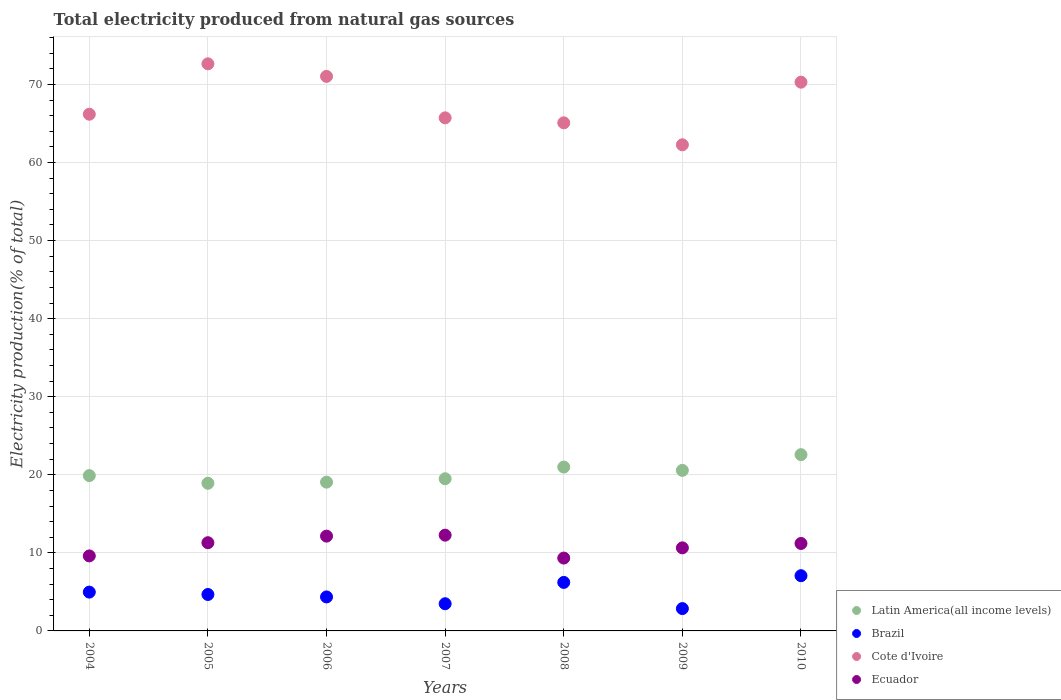Is the number of dotlines equal to the number of legend labels?
Provide a short and direct response. Yes. What is the total electricity produced in Latin America(all income levels) in 2008?
Your answer should be very brief. 20.99. Across all years, what is the maximum total electricity produced in Ecuador?
Offer a very short reply. 12.27. Across all years, what is the minimum total electricity produced in Ecuador?
Ensure brevity in your answer.  9.33. In which year was the total electricity produced in Brazil minimum?
Provide a succinct answer. 2009. What is the total total electricity produced in Ecuador in the graph?
Offer a very short reply. 76.49. What is the difference between the total electricity produced in Cote d'Ivoire in 2004 and that in 2010?
Keep it short and to the point. -4.1. What is the difference between the total electricity produced in Brazil in 2007 and the total electricity produced in Ecuador in 2009?
Ensure brevity in your answer.  -7.16. What is the average total electricity produced in Brazil per year?
Provide a succinct answer. 4.8. In the year 2010, what is the difference between the total electricity produced in Latin America(all income levels) and total electricity produced in Ecuador?
Your answer should be compact. 11.38. What is the ratio of the total electricity produced in Cote d'Ivoire in 2006 to that in 2008?
Keep it short and to the point. 1.09. Is the total electricity produced in Cote d'Ivoire in 2006 less than that in 2010?
Your response must be concise. No. Is the difference between the total electricity produced in Latin America(all income levels) in 2005 and 2006 greater than the difference between the total electricity produced in Ecuador in 2005 and 2006?
Your response must be concise. Yes. What is the difference between the highest and the second highest total electricity produced in Brazil?
Give a very brief answer. 0.86. What is the difference between the highest and the lowest total electricity produced in Cote d'Ivoire?
Make the answer very short. 10.37. In how many years, is the total electricity produced in Ecuador greater than the average total electricity produced in Ecuador taken over all years?
Offer a very short reply. 4. Is the sum of the total electricity produced in Cote d'Ivoire in 2004 and 2008 greater than the maximum total electricity produced in Latin America(all income levels) across all years?
Your answer should be compact. Yes. Is it the case that in every year, the sum of the total electricity produced in Cote d'Ivoire and total electricity produced in Ecuador  is greater than the total electricity produced in Latin America(all income levels)?
Offer a terse response. Yes. Is the total electricity produced in Cote d'Ivoire strictly less than the total electricity produced in Brazil over the years?
Provide a short and direct response. No. How many years are there in the graph?
Make the answer very short. 7. What is the difference between two consecutive major ticks on the Y-axis?
Provide a short and direct response. 10. Are the values on the major ticks of Y-axis written in scientific E-notation?
Provide a succinct answer. No. Does the graph contain grids?
Give a very brief answer. Yes. Where does the legend appear in the graph?
Your answer should be very brief. Bottom right. How many legend labels are there?
Provide a short and direct response. 4. How are the legend labels stacked?
Your answer should be very brief. Vertical. What is the title of the graph?
Keep it short and to the point. Total electricity produced from natural gas sources. Does "Philippines" appear as one of the legend labels in the graph?
Offer a very short reply. No. What is the label or title of the X-axis?
Make the answer very short. Years. What is the label or title of the Y-axis?
Your answer should be very brief. Electricity production(% of total). What is the Electricity production(% of total) in Latin America(all income levels) in 2004?
Your answer should be very brief. 19.9. What is the Electricity production(% of total) of Brazil in 2004?
Make the answer very short. 4.97. What is the Electricity production(% of total) in Cote d'Ivoire in 2004?
Your response must be concise. 66.19. What is the Electricity production(% of total) of Ecuador in 2004?
Keep it short and to the point. 9.61. What is the Electricity production(% of total) of Latin America(all income levels) in 2005?
Ensure brevity in your answer.  18.91. What is the Electricity production(% of total) in Brazil in 2005?
Your response must be concise. 4.67. What is the Electricity production(% of total) in Cote d'Ivoire in 2005?
Offer a terse response. 72.65. What is the Electricity production(% of total) of Ecuador in 2005?
Keep it short and to the point. 11.3. What is the Electricity production(% of total) of Latin America(all income levels) in 2006?
Make the answer very short. 19.06. What is the Electricity production(% of total) of Brazil in 2006?
Make the answer very short. 4.35. What is the Electricity production(% of total) of Cote d'Ivoire in 2006?
Your answer should be very brief. 71.03. What is the Electricity production(% of total) in Ecuador in 2006?
Offer a terse response. 12.14. What is the Electricity production(% of total) in Latin America(all income levels) in 2007?
Offer a very short reply. 19.49. What is the Electricity production(% of total) of Brazil in 2007?
Keep it short and to the point. 3.48. What is the Electricity production(% of total) of Cote d'Ivoire in 2007?
Provide a short and direct response. 65.73. What is the Electricity production(% of total) of Ecuador in 2007?
Offer a very short reply. 12.27. What is the Electricity production(% of total) of Latin America(all income levels) in 2008?
Your answer should be very brief. 20.99. What is the Electricity production(% of total) in Brazil in 2008?
Your answer should be compact. 6.21. What is the Electricity production(% of total) in Cote d'Ivoire in 2008?
Give a very brief answer. 65.09. What is the Electricity production(% of total) in Ecuador in 2008?
Offer a very short reply. 9.33. What is the Electricity production(% of total) of Latin America(all income levels) in 2009?
Your response must be concise. 20.57. What is the Electricity production(% of total) of Brazil in 2009?
Your answer should be compact. 2.86. What is the Electricity production(% of total) of Cote d'Ivoire in 2009?
Your answer should be compact. 62.27. What is the Electricity production(% of total) of Ecuador in 2009?
Keep it short and to the point. 10.64. What is the Electricity production(% of total) in Latin America(all income levels) in 2010?
Give a very brief answer. 22.58. What is the Electricity production(% of total) in Brazil in 2010?
Your answer should be compact. 7.07. What is the Electricity production(% of total) in Cote d'Ivoire in 2010?
Your answer should be very brief. 70.29. What is the Electricity production(% of total) of Ecuador in 2010?
Offer a terse response. 11.2. Across all years, what is the maximum Electricity production(% of total) in Latin America(all income levels)?
Your response must be concise. 22.58. Across all years, what is the maximum Electricity production(% of total) in Brazil?
Your response must be concise. 7.07. Across all years, what is the maximum Electricity production(% of total) of Cote d'Ivoire?
Offer a very short reply. 72.65. Across all years, what is the maximum Electricity production(% of total) of Ecuador?
Provide a short and direct response. 12.27. Across all years, what is the minimum Electricity production(% of total) of Latin America(all income levels)?
Ensure brevity in your answer.  18.91. Across all years, what is the minimum Electricity production(% of total) in Brazil?
Keep it short and to the point. 2.86. Across all years, what is the minimum Electricity production(% of total) in Cote d'Ivoire?
Provide a short and direct response. 62.27. Across all years, what is the minimum Electricity production(% of total) of Ecuador?
Offer a terse response. 9.33. What is the total Electricity production(% of total) of Latin America(all income levels) in the graph?
Your response must be concise. 141.5. What is the total Electricity production(% of total) in Brazil in the graph?
Offer a very short reply. 33.62. What is the total Electricity production(% of total) of Cote d'Ivoire in the graph?
Your answer should be very brief. 473.25. What is the total Electricity production(% of total) of Ecuador in the graph?
Keep it short and to the point. 76.49. What is the difference between the Electricity production(% of total) of Latin America(all income levels) in 2004 and that in 2005?
Make the answer very short. 0.98. What is the difference between the Electricity production(% of total) in Brazil in 2004 and that in 2005?
Your response must be concise. 0.3. What is the difference between the Electricity production(% of total) in Cote d'Ivoire in 2004 and that in 2005?
Your answer should be compact. -6.46. What is the difference between the Electricity production(% of total) of Ecuador in 2004 and that in 2005?
Offer a very short reply. -1.69. What is the difference between the Electricity production(% of total) of Latin America(all income levels) in 2004 and that in 2006?
Your answer should be compact. 0.84. What is the difference between the Electricity production(% of total) of Brazil in 2004 and that in 2006?
Offer a terse response. 0.62. What is the difference between the Electricity production(% of total) in Cote d'Ivoire in 2004 and that in 2006?
Your response must be concise. -4.85. What is the difference between the Electricity production(% of total) of Ecuador in 2004 and that in 2006?
Give a very brief answer. -2.53. What is the difference between the Electricity production(% of total) of Latin America(all income levels) in 2004 and that in 2007?
Provide a short and direct response. 0.4. What is the difference between the Electricity production(% of total) of Brazil in 2004 and that in 2007?
Your response must be concise. 1.49. What is the difference between the Electricity production(% of total) in Cote d'Ivoire in 2004 and that in 2007?
Ensure brevity in your answer.  0.46. What is the difference between the Electricity production(% of total) in Ecuador in 2004 and that in 2007?
Your answer should be very brief. -2.66. What is the difference between the Electricity production(% of total) of Latin America(all income levels) in 2004 and that in 2008?
Give a very brief answer. -1.1. What is the difference between the Electricity production(% of total) of Brazil in 2004 and that in 2008?
Give a very brief answer. -1.24. What is the difference between the Electricity production(% of total) in Cote d'Ivoire in 2004 and that in 2008?
Your answer should be very brief. 1.1. What is the difference between the Electricity production(% of total) in Ecuador in 2004 and that in 2008?
Offer a terse response. 0.28. What is the difference between the Electricity production(% of total) of Latin America(all income levels) in 2004 and that in 2009?
Offer a terse response. -0.67. What is the difference between the Electricity production(% of total) of Brazil in 2004 and that in 2009?
Your response must be concise. 2.11. What is the difference between the Electricity production(% of total) of Cote d'Ivoire in 2004 and that in 2009?
Make the answer very short. 3.92. What is the difference between the Electricity production(% of total) of Ecuador in 2004 and that in 2009?
Ensure brevity in your answer.  -1.03. What is the difference between the Electricity production(% of total) in Latin America(all income levels) in 2004 and that in 2010?
Make the answer very short. -2.68. What is the difference between the Electricity production(% of total) in Brazil in 2004 and that in 2010?
Offer a terse response. -2.1. What is the difference between the Electricity production(% of total) in Cote d'Ivoire in 2004 and that in 2010?
Your response must be concise. -4.1. What is the difference between the Electricity production(% of total) of Ecuador in 2004 and that in 2010?
Provide a short and direct response. -1.59. What is the difference between the Electricity production(% of total) of Latin America(all income levels) in 2005 and that in 2006?
Your answer should be very brief. -0.14. What is the difference between the Electricity production(% of total) of Brazil in 2005 and that in 2006?
Your response must be concise. 0.31. What is the difference between the Electricity production(% of total) in Cote d'Ivoire in 2005 and that in 2006?
Give a very brief answer. 1.61. What is the difference between the Electricity production(% of total) of Ecuador in 2005 and that in 2006?
Give a very brief answer. -0.84. What is the difference between the Electricity production(% of total) of Latin America(all income levels) in 2005 and that in 2007?
Your answer should be compact. -0.58. What is the difference between the Electricity production(% of total) of Brazil in 2005 and that in 2007?
Your response must be concise. 1.19. What is the difference between the Electricity production(% of total) of Cote d'Ivoire in 2005 and that in 2007?
Give a very brief answer. 6.92. What is the difference between the Electricity production(% of total) of Ecuador in 2005 and that in 2007?
Offer a terse response. -0.97. What is the difference between the Electricity production(% of total) of Latin America(all income levels) in 2005 and that in 2008?
Offer a very short reply. -2.08. What is the difference between the Electricity production(% of total) in Brazil in 2005 and that in 2008?
Offer a very short reply. -1.55. What is the difference between the Electricity production(% of total) of Cote d'Ivoire in 2005 and that in 2008?
Ensure brevity in your answer.  7.56. What is the difference between the Electricity production(% of total) of Ecuador in 2005 and that in 2008?
Your response must be concise. 1.97. What is the difference between the Electricity production(% of total) in Latin America(all income levels) in 2005 and that in 2009?
Your response must be concise. -1.65. What is the difference between the Electricity production(% of total) in Brazil in 2005 and that in 2009?
Give a very brief answer. 1.81. What is the difference between the Electricity production(% of total) of Cote d'Ivoire in 2005 and that in 2009?
Your answer should be compact. 10.37. What is the difference between the Electricity production(% of total) in Ecuador in 2005 and that in 2009?
Offer a terse response. 0.66. What is the difference between the Electricity production(% of total) of Latin America(all income levels) in 2005 and that in 2010?
Your response must be concise. -3.66. What is the difference between the Electricity production(% of total) of Brazil in 2005 and that in 2010?
Ensure brevity in your answer.  -2.4. What is the difference between the Electricity production(% of total) in Cote d'Ivoire in 2005 and that in 2010?
Your answer should be very brief. 2.35. What is the difference between the Electricity production(% of total) in Ecuador in 2005 and that in 2010?
Your answer should be very brief. 0.1. What is the difference between the Electricity production(% of total) in Latin America(all income levels) in 2006 and that in 2007?
Ensure brevity in your answer.  -0.43. What is the difference between the Electricity production(% of total) of Brazil in 2006 and that in 2007?
Your response must be concise. 0.87. What is the difference between the Electricity production(% of total) of Cote d'Ivoire in 2006 and that in 2007?
Keep it short and to the point. 5.31. What is the difference between the Electricity production(% of total) in Ecuador in 2006 and that in 2007?
Your answer should be compact. -0.12. What is the difference between the Electricity production(% of total) in Latin America(all income levels) in 2006 and that in 2008?
Your response must be concise. -1.93. What is the difference between the Electricity production(% of total) in Brazil in 2006 and that in 2008?
Your answer should be very brief. -1.86. What is the difference between the Electricity production(% of total) of Cote d'Ivoire in 2006 and that in 2008?
Provide a succinct answer. 5.95. What is the difference between the Electricity production(% of total) in Ecuador in 2006 and that in 2008?
Offer a very short reply. 2.81. What is the difference between the Electricity production(% of total) of Latin America(all income levels) in 2006 and that in 2009?
Your answer should be very brief. -1.51. What is the difference between the Electricity production(% of total) in Brazil in 2006 and that in 2009?
Give a very brief answer. 1.49. What is the difference between the Electricity production(% of total) of Cote d'Ivoire in 2006 and that in 2009?
Provide a succinct answer. 8.76. What is the difference between the Electricity production(% of total) in Ecuador in 2006 and that in 2009?
Give a very brief answer. 1.5. What is the difference between the Electricity production(% of total) of Latin America(all income levels) in 2006 and that in 2010?
Provide a short and direct response. -3.52. What is the difference between the Electricity production(% of total) of Brazil in 2006 and that in 2010?
Provide a succinct answer. -2.72. What is the difference between the Electricity production(% of total) of Cote d'Ivoire in 2006 and that in 2010?
Provide a short and direct response. 0.74. What is the difference between the Electricity production(% of total) in Ecuador in 2006 and that in 2010?
Make the answer very short. 0.94. What is the difference between the Electricity production(% of total) in Latin America(all income levels) in 2007 and that in 2008?
Your answer should be very brief. -1.5. What is the difference between the Electricity production(% of total) in Brazil in 2007 and that in 2008?
Your answer should be very brief. -2.73. What is the difference between the Electricity production(% of total) of Cote d'Ivoire in 2007 and that in 2008?
Offer a very short reply. 0.64. What is the difference between the Electricity production(% of total) in Ecuador in 2007 and that in 2008?
Keep it short and to the point. 2.93. What is the difference between the Electricity production(% of total) in Latin America(all income levels) in 2007 and that in 2009?
Provide a short and direct response. -1.07. What is the difference between the Electricity production(% of total) in Brazil in 2007 and that in 2009?
Your answer should be very brief. 0.62. What is the difference between the Electricity production(% of total) in Cote d'Ivoire in 2007 and that in 2009?
Keep it short and to the point. 3.45. What is the difference between the Electricity production(% of total) of Ecuador in 2007 and that in 2009?
Make the answer very short. 1.63. What is the difference between the Electricity production(% of total) in Latin America(all income levels) in 2007 and that in 2010?
Make the answer very short. -3.08. What is the difference between the Electricity production(% of total) in Brazil in 2007 and that in 2010?
Provide a succinct answer. -3.59. What is the difference between the Electricity production(% of total) of Cote d'Ivoire in 2007 and that in 2010?
Offer a very short reply. -4.57. What is the difference between the Electricity production(% of total) in Ecuador in 2007 and that in 2010?
Your answer should be compact. 1.07. What is the difference between the Electricity production(% of total) in Latin America(all income levels) in 2008 and that in 2009?
Give a very brief answer. 0.42. What is the difference between the Electricity production(% of total) in Brazil in 2008 and that in 2009?
Offer a very short reply. 3.35. What is the difference between the Electricity production(% of total) in Cote d'Ivoire in 2008 and that in 2009?
Offer a terse response. 2.81. What is the difference between the Electricity production(% of total) of Ecuador in 2008 and that in 2009?
Your answer should be compact. -1.31. What is the difference between the Electricity production(% of total) of Latin America(all income levels) in 2008 and that in 2010?
Offer a very short reply. -1.59. What is the difference between the Electricity production(% of total) in Brazil in 2008 and that in 2010?
Provide a short and direct response. -0.86. What is the difference between the Electricity production(% of total) of Cote d'Ivoire in 2008 and that in 2010?
Offer a very short reply. -5.21. What is the difference between the Electricity production(% of total) of Ecuador in 2008 and that in 2010?
Provide a succinct answer. -1.87. What is the difference between the Electricity production(% of total) in Latin America(all income levels) in 2009 and that in 2010?
Keep it short and to the point. -2.01. What is the difference between the Electricity production(% of total) in Brazil in 2009 and that in 2010?
Provide a short and direct response. -4.21. What is the difference between the Electricity production(% of total) in Cote d'Ivoire in 2009 and that in 2010?
Ensure brevity in your answer.  -8.02. What is the difference between the Electricity production(% of total) of Ecuador in 2009 and that in 2010?
Make the answer very short. -0.56. What is the difference between the Electricity production(% of total) in Latin America(all income levels) in 2004 and the Electricity production(% of total) in Brazil in 2005?
Offer a terse response. 15.23. What is the difference between the Electricity production(% of total) in Latin America(all income levels) in 2004 and the Electricity production(% of total) in Cote d'Ivoire in 2005?
Your answer should be compact. -52.75. What is the difference between the Electricity production(% of total) of Latin America(all income levels) in 2004 and the Electricity production(% of total) of Ecuador in 2005?
Your response must be concise. 8.6. What is the difference between the Electricity production(% of total) of Brazil in 2004 and the Electricity production(% of total) of Cote d'Ivoire in 2005?
Offer a terse response. -67.67. What is the difference between the Electricity production(% of total) of Brazil in 2004 and the Electricity production(% of total) of Ecuador in 2005?
Provide a succinct answer. -6.33. What is the difference between the Electricity production(% of total) of Cote d'Ivoire in 2004 and the Electricity production(% of total) of Ecuador in 2005?
Your answer should be compact. 54.89. What is the difference between the Electricity production(% of total) in Latin America(all income levels) in 2004 and the Electricity production(% of total) in Brazil in 2006?
Offer a very short reply. 15.54. What is the difference between the Electricity production(% of total) of Latin America(all income levels) in 2004 and the Electricity production(% of total) of Cote d'Ivoire in 2006?
Your answer should be very brief. -51.14. What is the difference between the Electricity production(% of total) in Latin America(all income levels) in 2004 and the Electricity production(% of total) in Ecuador in 2006?
Provide a succinct answer. 7.75. What is the difference between the Electricity production(% of total) of Brazil in 2004 and the Electricity production(% of total) of Cote d'Ivoire in 2006?
Offer a terse response. -66.06. What is the difference between the Electricity production(% of total) in Brazil in 2004 and the Electricity production(% of total) in Ecuador in 2006?
Offer a terse response. -7.17. What is the difference between the Electricity production(% of total) in Cote d'Ivoire in 2004 and the Electricity production(% of total) in Ecuador in 2006?
Keep it short and to the point. 54.05. What is the difference between the Electricity production(% of total) in Latin America(all income levels) in 2004 and the Electricity production(% of total) in Brazil in 2007?
Your answer should be compact. 16.41. What is the difference between the Electricity production(% of total) in Latin America(all income levels) in 2004 and the Electricity production(% of total) in Cote d'Ivoire in 2007?
Your answer should be very brief. -45.83. What is the difference between the Electricity production(% of total) in Latin America(all income levels) in 2004 and the Electricity production(% of total) in Ecuador in 2007?
Offer a terse response. 7.63. What is the difference between the Electricity production(% of total) of Brazil in 2004 and the Electricity production(% of total) of Cote d'Ivoire in 2007?
Give a very brief answer. -60.75. What is the difference between the Electricity production(% of total) of Brazil in 2004 and the Electricity production(% of total) of Ecuador in 2007?
Provide a succinct answer. -7.29. What is the difference between the Electricity production(% of total) in Cote d'Ivoire in 2004 and the Electricity production(% of total) in Ecuador in 2007?
Offer a terse response. 53.92. What is the difference between the Electricity production(% of total) in Latin America(all income levels) in 2004 and the Electricity production(% of total) in Brazil in 2008?
Offer a very short reply. 13.68. What is the difference between the Electricity production(% of total) of Latin America(all income levels) in 2004 and the Electricity production(% of total) of Cote d'Ivoire in 2008?
Give a very brief answer. -45.19. What is the difference between the Electricity production(% of total) in Latin America(all income levels) in 2004 and the Electricity production(% of total) in Ecuador in 2008?
Provide a short and direct response. 10.56. What is the difference between the Electricity production(% of total) of Brazil in 2004 and the Electricity production(% of total) of Cote d'Ivoire in 2008?
Give a very brief answer. -60.11. What is the difference between the Electricity production(% of total) in Brazil in 2004 and the Electricity production(% of total) in Ecuador in 2008?
Provide a succinct answer. -4.36. What is the difference between the Electricity production(% of total) in Cote d'Ivoire in 2004 and the Electricity production(% of total) in Ecuador in 2008?
Keep it short and to the point. 56.86. What is the difference between the Electricity production(% of total) in Latin America(all income levels) in 2004 and the Electricity production(% of total) in Brazil in 2009?
Keep it short and to the point. 17.03. What is the difference between the Electricity production(% of total) of Latin America(all income levels) in 2004 and the Electricity production(% of total) of Cote d'Ivoire in 2009?
Offer a terse response. -42.38. What is the difference between the Electricity production(% of total) of Latin America(all income levels) in 2004 and the Electricity production(% of total) of Ecuador in 2009?
Provide a succinct answer. 9.25. What is the difference between the Electricity production(% of total) in Brazil in 2004 and the Electricity production(% of total) in Cote d'Ivoire in 2009?
Make the answer very short. -57.3. What is the difference between the Electricity production(% of total) in Brazil in 2004 and the Electricity production(% of total) in Ecuador in 2009?
Your answer should be very brief. -5.67. What is the difference between the Electricity production(% of total) in Cote d'Ivoire in 2004 and the Electricity production(% of total) in Ecuador in 2009?
Ensure brevity in your answer.  55.55. What is the difference between the Electricity production(% of total) of Latin America(all income levels) in 2004 and the Electricity production(% of total) of Brazil in 2010?
Offer a very short reply. 12.82. What is the difference between the Electricity production(% of total) in Latin America(all income levels) in 2004 and the Electricity production(% of total) in Cote d'Ivoire in 2010?
Make the answer very short. -50.4. What is the difference between the Electricity production(% of total) of Latin America(all income levels) in 2004 and the Electricity production(% of total) of Ecuador in 2010?
Ensure brevity in your answer.  8.69. What is the difference between the Electricity production(% of total) of Brazil in 2004 and the Electricity production(% of total) of Cote d'Ivoire in 2010?
Keep it short and to the point. -65.32. What is the difference between the Electricity production(% of total) in Brazil in 2004 and the Electricity production(% of total) in Ecuador in 2010?
Your response must be concise. -6.23. What is the difference between the Electricity production(% of total) in Cote d'Ivoire in 2004 and the Electricity production(% of total) in Ecuador in 2010?
Ensure brevity in your answer.  54.99. What is the difference between the Electricity production(% of total) in Latin America(all income levels) in 2005 and the Electricity production(% of total) in Brazil in 2006?
Make the answer very short. 14.56. What is the difference between the Electricity production(% of total) in Latin America(all income levels) in 2005 and the Electricity production(% of total) in Cote d'Ivoire in 2006?
Offer a terse response. -52.12. What is the difference between the Electricity production(% of total) in Latin America(all income levels) in 2005 and the Electricity production(% of total) in Ecuador in 2006?
Give a very brief answer. 6.77. What is the difference between the Electricity production(% of total) of Brazil in 2005 and the Electricity production(% of total) of Cote d'Ivoire in 2006?
Provide a short and direct response. -66.37. What is the difference between the Electricity production(% of total) of Brazil in 2005 and the Electricity production(% of total) of Ecuador in 2006?
Offer a terse response. -7.48. What is the difference between the Electricity production(% of total) in Cote d'Ivoire in 2005 and the Electricity production(% of total) in Ecuador in 2006?
Your answer should be very brief. 60.5. What is the difference between the Electricity production(% of total) of Latin America(all income levels) in 2005 and the Electricity production(% of total) of Brazil in 2007?
Ensure brevity in your answer.  15.43. What is the difference between the Electricity production(% of total) in Latin America(all income levels) in 2005 and the Electricity production(% of total) in Cote d'Ivoire in 2007?
Your answer should be very brief. -46.81. What is the difference between the Electricity production(% of total) in Latin America(all income levels) in 2005 and the Electricity production(% of total) in Ecuador in 2007?
Provide a short and direct response. 6.65. What is the difference between the Electricity production(% of total) of Brazil in 2005 and the Electricity production(% of total) of Cote d'Ivoire in 2007?
Offer a terse response. -61.06. What is the difference between the Electricity production(% of total) of Brazil in 2005 and the Electricity production(% of total) of Ecuador in 2007?
Make the answer very short. -7.6. What is the difference between the Electricity production(% of total) of Cote d'Ivoire in 2005 and the Electricity production(% of total) of Ecuador in 2007?
Provide a succinct answer. 60.38. What is the difference between the Electricity production(% of total) of Latin America(all income levels) in 2005 and the Electricity production(% of total) of Brazil in 2008?
Your response must be concise. 12.7. What is the difference between the Electricity production(% of total) in Latin America(all income levels) in 2005 and the Electricity production(% of total) in Cote d'Ivoire in 2008?
Keep it short and to the point. -46.17. What is the difference between the Electricity production(% of total) in Latin America(all income levels) in 2005 and the Electricity production(% of total) in Ecuador in 2008?
Ensure brevity in your answer.  9.58. What is the difference between the Electricity production(% of total) of Brazil in 2005 and the Electricity production(% of total) of Cote d'Ivoire in 2008?
Give a very brief answer. -60.42. What is the difference between the Electricity production(% of total) of Brazil in 2005 and the Electricity production(% of total) of Ecuador in 2008?
Give a very brief answer. -4.67. What is the difference between the Electricity production(% of total) in Cote d'Ivoire in 2005 and the Electricity production(% of total) in Ecuador in 2008?
Provide a succinct answer. 63.31. What is the difference between the Electricity production(% of total) of Latin America(all income levels) in 2005 and the Electricity production(% of total) of Brazil in 2009?
Your answer should be compact. 16.05. What is the difference between the Electricity production(% of total) of Latin America(all income levels) in 2005 and the Electricity production(% of total) of Cote d'Ivoire in 2009?
Your answer should be very brief. -43.36. What is the difference between the Electricity production(% of total) of Latin America(all income levels) in 2005 and the Electricity production(% of total) of Ecuador in 2009?
Ensure brevity in your answer.  8.27. What is the difference between the Electricity production(% of total) in Brazil in 2005 and the Electricity production(% of total) in Cote d'Ivoire in 2009?
Your answer should be very brief. -57.6. What is the difference between the Electricity production(% of total) of Brazil in 2005 and the Electricity production(% of total) of Ecuador in 2009?
Ensure brevity in your answer.  -5.97. What is the difference between the Electricity production(% of total) of Cote d'Ivoire in 2005 and the Electricity production(% of total) of Ecuador in 2009?
Ensure brevity in your answer.  62. What is the difference between the Electricity production(% of total) in Latin America(all income levels) in 2005 and the Electricity production(% of total) in Brazil in 2010?
Offer a terse response. 11.84. What is the difference between the Electricity production(% of total) in Latin America(all income levels) in 2005 and the Electricity production(% of total) in Cote d'Ivoire in 2010?
Ensure brevity in your answer.  -51.38. What is the difference between the Electricity production(% of total) of Latin America(all income levels) in 2005 and the Electricity production(% of total) of Ecuador in 2010?
Give a very brief answer. 7.71. What is the difference between the Electricity production(% of total) in Brazil in 2005 and the Electricity production(% of total) in Cote d'Ivoire in 2010?
Provide a succinct answer. -65.63. What is the difference between the Electricity production(% of total) of Brazil in 2005 and the Electricity production(% of total) of Ecuador in 2010?
Your answer should be compact. -6.53. What is the difference between the Electricity production(% of total) in Cote d'Ivoire in 2005 and the Electricity production(% of total) in Ecuador in 2010?
Offer a very short reply. 61.44. What is the difference between the Electricity production(% of total) in Latin America(all income levels) in 2006 and the Electricity production(% of total) in Brazil in 2007?
Ensure brevity in your answer.  15.58. What is the difference between the Electricity production(% of total) in Latin America(all income levels) in 2006 and the Electricity production(% of total) in Cote d'Ivoire in 2007?
Your response must be concise. -46.67. What is the difference between the Electricity production(% of total) in Latin America(all income levels) in 2006 and the Electricity production(% of total) in Ecuador in 2007?
Make the answer very short. 6.79. What is the difference between the Electricity production(% of total) of Brazil in 2006 and the Electricity production(% of total) of Cote d'Ivoire in 2007?
Offer a very short reply. -61.37. What is the difference between the Electricity production(% of total) in Brazil in 2006 and the Electricity production(% of total) in Ecuador in 2007?
Provide a short and direct response. -7.91. What is the difference between the Electricity production(% of total) of Cote d'Ivoire in 2006 and the Electricity production(% of total) of Ecuador in 2007?
Provide a succinct answer. 58.77. What is the difference between the Electricity production(% of total) of Latin America(all income levels) in 2006 and the Electricity production(% of total) of Brazil in 2008?
Ensure brevity in your answer.  12.84. What is the difference between the Electricity production(% of total) in Latin America(all income levels) in 2006 and the Electricity production(% of total) in Cote d'Ivoire in 2008?
Offer a terse response. -46.03. What is the difference between the Electricity production(% of total) of Latin America(all income levels) in 2006 and the Electricity production(% of total) of Ecuador in 2008?
Give a very brief answer. 9.73. What is the difference between the Electricity production(% of total) in Brazil in 2006 and the Electricity production(% of total) in Cote d'Ivoire in 2008?
Offer a terse response. -60.73. What is the difference between the Electricity production(% of total) of Brazil in 2006 and the Electricity production(% of total) of Ecuador in 2008?
Your answer should be compact. -4.98. What is the difference between the Electricity production(% of total) in Cote d'Ivoire in 2006 and the Electricity production(% of total) in Ecuador in 2008?
Keep it short and to the point. 61.7. What is the difference between the Electricity production(% of total) of Latin America(all income levels) in 2006 and the Electricity production(% of total) of Brazil in 2009?
Your answer should be very brief. 16.2. What is the difference between the Electricity production(% of total) in Latin America(all income levels) in 2006 and the Electricity production(% of total) in Cote d'Ivoire in 2009?
Ensure brevity in your answer.  -43.21. What is the difference between the Electricity production(% of total) of Latin America(all income levels) in 2006 and the Electricity production(% of total) of Ecuador in 2009?
Your response must be concise. 8.42. What is the difference between the Electricity production(% of total) of Brazil in 2006 and the Electricity production(% of total) of Cote d'Ivoire in 2009?
Your answer should be very brief. -57.92. What is the difference between the Electricity production(% of total) in Brazil in 2006 and the Electricity production(% of total) in Ecuador in 2009?
Keep it short and to the point. -6.29. What is the difference between the Electricity production(% of total) of Cote d'Ivoire in 2006 and the Electricity production(% of total) of Ecuador in 2009?
Ensure brevity in your answer.  60.39. What is the difference between the Electricity production(% of total) of Latin America(all income levels) in 2006 and the Electricity production(% of total) of Brazil in 2010?
Offer a terse response. 11.99. What is the difference between the Electricity production(% of total) in Latin America(all income levels) in 2006 and the Electricity production(% of total) in Cote d'Ivoire in 2010?
Offer a very short reply. -51.23. What is the difference between the Electricity production(% of total) in Latin America(all income levels) in 2006 and the Electricity production(% of total) in Ecuador in 2010?
Ensure brevity in your answer.  7.86. What is the difference between the Electricity production(% of total) in Brazil in 2006 and the Electricity production(% of total) in Cote d'Ivoire in 2010?
Ensure brevity in your answer.  -65.94. What is the difference between the Electricity production(% of total) of Brazil in 2006 and the Electricity production(% of total) of Ecuador in 2010?
Your response must be concise. -6.85. What is the difference between the Electricity production(% of total) in Cote d'Ivoire in 2006 and the Electricity production(% of total) in Ecuador in 2010?
Keep it short and to the point. 59.83. What is the difference between the Electricity production(% of total) of Latin America(all income levels) in 2007 and the Electricity production(% of total) of Brazil in 2008?
Provide a short and direct response. 13.28. What is the difference between the Electricity production(% of total) of Latin America(all income levels) in 2007 and the Electricity production(% of total) of Cote d'Ivoire in 2008?
Offer a terse response. -45.59. What is the difference between the Electricity production(% of total) of Latin America(all income levels) in 2007 and the Electricity production(% of total) of Ecuador in 2008?
Offer a terse response. 10.16. What is the difference between the Electricity production(% of total) in Brazil in 2007 and the Electricity production(% of total) in Cote d'Ivoire in 2008?
Your answer should be very brief. -61.61. What is the difference between the Electricity production(% of total) in Brazil in 2007 and the Electricity production(% of total) in Ecuador in 2008?
Provide a short and direct response. -5.85. What is the difference between the Electricity production(% of total) in Cote d'Ivoire in 2007 and the Electricity production(% of total) in Ecuador in 2008?
Ensure brevity in your answer.  56.39. What is the difference between the Electricity production(% of total) in Latin America(all income levels) in 2007 and the Electricity production(% of total) in Brazil in 2009?
Provide a short and direct response. 16.63. What is the difference between the Electricity production(% of total) of Latin America(all income levels) in 2007 and the Electricity production(% of total) of Cote d'Ivoire in 2009?
Your response must be concise. -42.78. What is the difference between the Electricity production(% of total) of Latin America(all income levels) in 2007 and the Electricity production(% of total) of Ecuador in 2009?
Offer a very short reply. 8.85. What is the difference between the Electricity production(% of total) in Brazil in 2007 and the Electricity production(% of total) in Cote d'Ivoire in 2009?
Your answer should be compact. -58.79. What is the difference between the Electricity production(% of total) in Brazil in 2007 and the Electricity production(% of total) in Ecuador in 2009?
Offer a very short reply. -7.16. What is the difference between the Electricity production(% of total) of Cote d'Ivoire in 2007 and the Electricity production(% of total) of Ecuador in 2009?
Give a very brief answer. 55.08. What is the difference between the Electricity production(% of total) of Latin America(all income levels) in 2007 and the Electricity production(% of total) of Brazil in 2010?
Keep it short and to the point. 12.42. What is the difference between the Electricity production(% of total) of Latin America(all income levels) in 2007 and the Electricity production(% of total) of Cote d'Ivoire in 2010?
Give a very brief answer. -50.8. What is the difference between the Electricity production(% of total) in Latin America(all income levels) in 2007 and the Electricity production(% of total) in Ecuador in 2010?
Make the answer very short. 8.29. What is the difference between the Electricity production(% of total) in Brazil in 2007 and the Electricity production(% of total) in Cote d'Ivoire in 2010?
Give a very brief answer. -66.81. What is the difference between the Electricity production(% of total) of Brazil in 2007 and the Electricity production(% of total) of Ecuador in 2010?
Provide a short and direct response. -7.72. What is the difference between the Electricity production(% of total) of Cote d'Ivoire in 2007 and the Electricity production(% of total) of Ecuador in 2010?
Offer a terse response. 54.52. What is the difference between the Electricity production(% of total) in Latin America(all income levels) in 2008 and the Electricity production(% of total) in Brazil in 2009?
Your answer should be very brief. 18.13. What is the difference between the Electricity production(% of total) of Latin America(all income levels) in 2008 and the Electricity production(% of total) of Cote d'Ivoire in 2009?
Provide a succinct answer. -41.28. What is the difference between the Electricity production(% of total) of Latin America(all income levels) in 2008 and the Electricity production(% of total) of Ecuador in 2009?
Give a very brief answer. 10.35. What is the difference between the Electricity production(% of total) in Brazil in 2008 and the Electricity production(% of total) in Cote d'Ivoire in 2009?
Your response must be concise. -56.06. What is the difference between the Electricity production(% of total) in Brazil in 2008 and the Electricity production(% of total) in Ecuador in 2009?
Offer a terse response. -4.43. What is the difference between the Electricity production(% of total) in Cote d'Ivoire in 2008 and the Electricity production(% of total) in Ecuador in 2009?
Ensure brevity in your answer.  54.44. What is the difference between the Electricity production(% of total) in Latin America(all income levels) in 2008 and the Electricity production(% of total) in Brazil in 2010?
Ensure brevity in your answer.  13.92. What is the difference between the Electricity production(% of total) of Latin America(all income levels) in 2008 and the Electricity production(% of total) of Cote d'Ivoire in 2010?
Provide a succinct answer. -49.3. What is the difference between the Electricity production(% of total) in Latin America(all income levels) in 2008 and the Electricity production(% of total) in Ecuador in 2010?
Provide a short and direct response. 9.79. What is the difference between the Electricity production(% of total) in Brazil in 2008 and the Electricity production(% of total) in Cote d'Ivoire in 2010?
Make the answer very short. -64.08. What is the difference between the Electricity production(% of total) of Brazil in 2008 and the Electricity production(% of total) of Ecuador in 2010?
Keep it short and to the point. -4.99. What is the difference between the Electricity production(% of total) in Cote d'Ivoire in 2008 and the Electricity production(% of total) in Ecuador in 2010?
Ensure brevity in your answer.  53.88. What is the difference between the Electricity production(% of total) of Latin America(all income levels) in 2009 and the Electricity production(% of total) of Brazil in 2010?
Make the answer very short. 13.49. What is the difference between the Electricity production(% of total) in Latin America(all income levels) in 2009 and the Electricity production(% of total) in Cote d'Ivoire in 2010?
Provide a succinct answer. -49.73. What is the difference between the Electricity production(% of total) of Latin America(all income levels) in 2009 and the Electricity production(% of total) of Ecuador in 2010?
Offer a very short reply. 9.36. What is the difference between the Electricity production(% of total) of Brazil in 2009 and the Electricity production(% of total) of Cote d'Ivoire in 2010?
Offer a terse response. -67.43. What is the difference between the Electricity production(% of total) in Brazil in 2009 and the Electricity production(% of total) in Ecuador in 2010?
Ensure brevity in your answer.  -8.34. What is the difference between the Electricity production(% of total) in Cote d'Ivoire in 2009 and the Electricity production(% of total) in Ecuador in 2010?
Offer a terse response. 51.07. What is the average Electricity production(% of total) in Latin America(all income levels) per year?
Provide a succinct answer. 20.21. What is the average Electricity production(% of total) of Brazil per year?
Make the answer very short. 4.8. What is the average Electricity production(% of total) of Cote d'Ivoire per year?
Your answer should be compact. 67.61. What is the average Electricity production(% of total) of Ecuador per year?
Your response must be concise. 10.93. In the year 2004, what is the difference between the Electricity production(% of total) of Latin America(all income levels) and Electricity production(% of total) of Brazil?
Give a very brief answer. 14.92. In the year 2004, what is the difference between the Electricity production(% of total) of Latin America(all income levels) and Electricity production(% of total) of Cote d'Ivoire?
Offer a very short reply. -46.29. In the year 2004, what is the difference between the Electricity production(% of total) in Latin America(all income levels) and Electricity production(% of total) in Ecuador?
Keep it short and to the point. 10.29. In the year 2004, what is the difference between the Electricity production(% of total) of Brazil and Electricity production(% of total) of Cote d'Ivoire?
Offer a very short reply. -61.22. In the year 2004, what is the difference between the Electricity production(% of total) in Brazil and Electricity production(% of total) in Ecuador?
Provide a succinct answer. -4.64. In the year 2004, what is the difference between the Electricity production(% of total) of Cote d'Ivoire and Electricity production(% of total) of Ecuador?
Make the answer very short. 56.58. In the year 2005, what is the difference between the Electricity production(% of total) of Latin America(all income levels) and Electricity production(% of total) of Brazil?
Your answer should be compact. 14.25. In the year 2005, what is the difference between the Electricity production(% of total) in Latin America(all income levels) and Electricity production(% of total) in Cote d'Ivoire?
Your answer should be compact. -53.73. In the year 2005, what is the difference between the Electricity production(% of total) of Latin America(all income levels) and Electricity production(% of total) of Ecuador?
Give a very brief answer. 7.61. In the year 2005, what is the difference between the Electricity production(% of total) of Brazil and Electricity production(% of total) of Cote d'Ivoire?
Offer a very short reply. -67.98. In the year 2005, what is the difference between the Electricity production(% of total) in Brazil and Electricity production(% of total) in Ecuador?
Offer a terse response. -6.63. In the year 2005, what is the difference between the Electricity production(% of total) of Cote d'Ivoire and Electricity production(% of total) of Ecuador?
Your response must be concise. 61.35. In the year 2006, what is the difference between the Electricity production(% of total) in Latin America(all income levels) and Electricity production(% of total) in Brazil?
Your answer should be very brief. 14.71. In the year 2006, what is the difference between the Electricity production(% of total) in Latin America(all income levels) and Electricity production(% of total) in Cote d'Ivoire?
Your answer should be very brief. -51.98. In the year 2006, what is the difference between the Electricity production(% of total) in Latin America(all income levels) and Electricity production(% of total) in Ecuador?
Your answer should be very brief. 6.92. In the year 2006, what is the difference between the Electricity production(% of total) in Brazil and Electricity production(% of total) in Cote d'Ivoire?
Keep it short and to the point. -66.68. In the year 2006, what is the difference between the Electricity production(% of total) of Brazil and Electricity production(% of total) of Ecuador?
Make the answer very short. -7.79. In the year 2006, what is the difference between the Electricity production(% of total) of Cote d'Ivoire and Electricity production(% of total) of Ecuador?
Keep it short and to the point. 58.89. In the year 2007, what is the difference between the Electricity production(% of total) of Latin America(all income levels) and Electricity production(% of total) of Brazil?
Keep it short and to the point. 16.01. In the year 2007, what is the difference between the Electricity production(% of total) of Latin America(all income levels) and Electricity production(% of total) of Cote d'Ivoire?
Your response must be concise. -46.23. In the year 2007, what is the difference between the Electricity production(% of total) in Latin America(all income levels) and Electricity production(% of total) in Ecuador?
Offer a terse response. 7.23. In the year 2007, what is the difference between the Electricity production(% of total) of Brazil and Electricity production(% of total) of Cote d'Ivoire?
Ensure brevity in your answer.  -62.24. In the year 2007, what is the difference between the Electricity production(% of total) of Brazil and Electricity production(% of total) of Ecuador?
Provide a short and direct response. -8.79. In the year 2007, what is the difference between the Electricity production(% of total) of Cote d'Ivoire and Electricity production(% of total) of Ecuador?
Your response must be concise. 53.46. In the year 2008, what is the difference between the Electricity production(% of total) of Latin America(all income levels) and Electricity production(% of total) of Brazil?
Offer a very short reply. 14.78. In the year 2008, what is the difference between the Electricity production(% of total) of Latin America(all income levels) and Electricity production(% of total) of Cote d'Ivoire?
Give a very brief answer. -44.1. In the year 2008, what is the difference between the Electricity production(% of total) in Latin America(all income levels) and Electricity production(% of total) in Ecuador?
Your response must be concise. 11.66. In the year 2008, what is the difference between the Electricity production(% of total) of Brazil and Electricity production(% of total) of Cote d'Ivoire?
Provide a succinct answer. -58.87. In the year 2008, what is the difference between the Electricity production(% of total) in Brazil and Electricity production(% of total) in Ecuador?
Your answer should be compact. -3.12. In the year 2008, what is the difference between the Electricity production(% of total) in Cote d'Ivoire and Electricity production(% of total) in Ecuador?
Your answer should be very brief. 55.75. In the year 2009, what is the difference between the Electricity production(% of total) in Latin America(all income levels) and Electricity production(% of total) in Brazil?
Keep it short and to the point. 17.71. In the year 2009, what is the difference between the Electricity production(% of total) of Latin America(all income levels) and Electricity production(% of total) of Cote d'Ivoire?
Offer a very short reply. -41.71. In the year 2009, what is the difference between the Electricity production(% of total) of Latin America(all income levels) and Electricity production(% of total) of Ecuador?
Ensure brevity in your answer.  9.92. In the year 2009, what is the difference between the Electricity production(% of total) of Brazil and Electricity production(% of total) of Cote d'Ivoire?
Your answer should be very brief. -59.41. In the year 2009, what is the difference between the Electricity production(% of total) in Brazil and Electricity production(% of total) in Ecuador?
Provide a short and direct response. -7.78. In the year 2009, what is the difference between the Electricity production(% of total) of Cote d'Ivoire and Electricity production(% of total) of Ecuador?
Provide a succinct answer. 51.63. In the year 2010, what is the difference between the Electricity production(% of total) of Latin America(all income levels) and Electricity production(% of total) of Brazil?
Ensure brevity in your answer.  15.51. In the year 2010, what is the difference between the Electricity production(% of total) in Latin America(all income levels) and Electricity production(% of total) in Cote d'Ivoire?
Your answer should be very brief. -47.72. In the year 2010, what is the difference between the Electricity production(% of total) in Latin America(all income levels) and Electricity production(% of total) in Ecuador?
Provide a succinct answer. 11.38. In the year 2010, what is the difference between the Electricity production(% of total) of Brazil and Electricity production(% of total) of Cote d'Ivoire?
Provide a succinct answer. -63.22. In the year 2010, what is the difference between the Electricity production(% of total) in Brazil and Electricity production(% of total) in Ecuador?
Give a very brief answer. -4.13. In the year 2010, what is the difference between the Electricity production(% of total) of Cote d'Ivoire and Electricity production(% of total) of Ecuador?
Ensure brevity in your answer.  59.09. What is the ratio of the Electricity production(% of total) in Latin America(all income levels) in 2004 to that in 2005?
Offer a very short reply. 1.05. What is the ratio of the Electricity production(% of total) in Brazil in 2004 to that in 2005?
Give a very brief answer. 1.07. What is the ratio of the Electricity production(% of total) of Cote d'Ivoire in 2004 to that in 2005?
Your response must be concise. 0.91. What is the ratio of the Electricity production(% of total) of Ecuador in 2004 to that in 2005?
Your answer should be compact. 0.85. What is the ratio of the Electricity production(% of total) of Latin America(all income levels) in 2004 to that in 2006?
Your answer should be very brief. 1.04. What is the ratio of the Electricity production(% of total) of Brazil in 2004 to that in 2006?
Give a very brief answer. 1.14. What is the ratio of the Electricity production(% of total) in Cote d'Ivoire in 2004 to that in 2006?
Keep it short and to the point. 0.93. What is the ratio of the Electricity production(% of total) of Ecuador in 2004 to that in 2006?
Keep it short and to the point. 0.79. What is the ratio of the Electricity production(% of total) in Latin America(all income levels) in 2004 to that in 2007?
Ensure brevity in your answer.  1.02. What is the ratio of the Electricity production(% of total) of Brazil in 2004 to that in 2007?
Keep it short and to the point. 1.43. What is the ratio of the Electricity production(% of total) in Ecuador in 2004 to that in 2007?
Ensure brevity in your answer.  0.78. What is the ratio of the Electricity production(% of total) in Latin America(all income levels) in 2004 to that in 2008?
Ensure brevity in your answer.  0.95. What is the ratio of the Electricity production(% of total) of Cote d'Ivoire in 2004 to that in 2008?
Make the answer very short. 1.02. What is the ratio of the Electricity production(% of total) of Ecuador in 2004 to that in 2008?
Make the answer very short. 1.03. What is the ratio of the Electricity production(% of total) of Latin America(all income levels) in 2004 to that in 2009?
Provide a succinct answer. 0.97. What is the ratio of the Electricity production(% of total) in Brazil in 2004 to that in 2009?
Make the answer very short. 1.74. What is the ratio of the Electricity production(% of total) of Cote d'Ivoire in 2004 to that in 2009?
Offer a terse response. 1.06. What is the ratio of the Electricity production(% of total) in Ecuador in 2004 to that in 2009?
Keep it short and to the point. 0.9. What is the ratio of the Electricity production(% of total) of Latin America(all income levels) in 2004 to that in 2010?
Ensure brevity in your answer.  0.88. What is the ratio of the Electricity production(% of total) of Brazil in 2004 to that in 2010?
Your answer should be very brief. 0.7. What is the ratio of the Electricity production(% of total) in Cote d'Ivoire in 2004 to that in 2010?
Your response must be concise. 0.94. What is the ratio of the Electricity production(% of total) of Ecuador in 2004 to that in 2010?
Provide a short and direct response. 0.86. What is the ratio of the Electricity production(% of total) in Brazil in 2005 to that in 2006?
Provide a succinct answer. 1.07. What is the ratio of the Electricity production(% of total) of Cote d'Ivoire in 2005 to that in 2006?
Make the answer very short. 1.02. What is the ratio of the Electricity production(% of total) in Ecuador in 2005 to that in 2006?
Offer a very short reply. 0.93. What is the ratio of the Electricity production(% of total) of Latin America(all income levels) in 2005 to that in 2007?
Make the answer very short. 0.97. What is the ratio of the Electricity production(% of total) of Brazil in 2005 to that in 2007?
Give a very brief answer. 1.34. What is the ratio of the Electricity production(% of total) of Cote d'Ivoire in 2005 to that in 2007?
Offer a very short reply. 1.11. What is the ratio of the Electricity production(% of total) in Ecuador in 2005 to that in 2007?
Keep it short and to the point. 0.92. What is the ratio of the Electricity production(% of total) of Latin America(all income levels) in 2005 to that in 2008?
Make the answer very short. 0.9. What is the ratio of the Electricity production(% of total) in Brazil in 2005 to that in 2008?
Make the answer very short. 0.75. What is the ratio of the Electricity production(% of total) in Cote d'Ivoire in 2005 to that in 2008?
Make the answer very short. 1.12. What is the ratio of the Electricity production(% of total) of Ecuador in 2005 to that in 2008?
Keep it short and to the point. 1.21. What is the ratio of the Electricity production(% of total) in Latin America(all income levels) in 2005 to that in 2009?
Your answer should be compact. 0.92. What is the ratio of the Electricity production(% of total) in Brazil in 2005 to that in 2009?
Make the answer very short. 1.63. What is the ratio of the Electricity production(% of total) in Cote d'Ivoire in 2005 to that in 2009?
Give a very brief answer. 1.17. What is the ratio of the Electricity production(% of total) of Ecuador in 2005 to that in 2009?
Offer a terse response. 1.06. What is the ratio of the Electricity production(% of total) in Latin America(all income levels) in 2005 to that in 2010?
Ensure brevity in your answer.  0.84. What is the ratio of the Electricity production(% of total) in Brazil in 2005 to that in 2010?
Your response must be concise. 0.66. What is the ratio of the Electricity production(% of total) of Cote d'Ivoire in 2005 to that in 2010?
Provide a succinct answer. 1.03. What is the ratio of the Electricity production(% of total) in Ecuador in 2005 to that in 2010?
Give a very brief answer. 1.01. What is the ratio of the Electricity production(% of total) in Latin America(all income levels) in 2006 to that in 2007?
Give a very brief answer. 0.98. What is the ratio of the Electricity production(% of total) in Brazil in 2006 to that in 2007?
Offer a very short reply. 1.25. What is the ratio of the Electricity production(% of total) of Cote d'Ivoire in 2006 to that in 2007?
Your response must be concise. 1.08. What is the ratio of the Electricity production(% of total) of Ecuador in 2006 to that in 2007?
Provide a succinct answer. 0.99. What is the ratio of the Electricity production(% of total) in Latin America(all income levels) in 2006 to that in 2008?
Your answer should be compact. 0.91. What is the ratio of the Electricity production(% of total) of Brazil in 2006 to that in 2008?
Provide a short and direct response. 0.7. What is the ratio of the Electricity production(% of total) of Cote d'Ivoire in 2006 to that in 2008?
Offer a terse response. 1.09. What is the ratio of the Electricity production(% of total) in Ecuador in 2006 to that in 2008?
Your answer should be very brief. 1.3. What is the ratio of the Electricity production(% of total) in Latin America(all income levels) in 2006 to that in 2009?
Your response must be concise. 0.93. What is the ratio of the Electricity production(% of total) in Brazil in 2006 to that in 2009?
Offer a very short reply. 1.52. What is the ratio of the Electricity production(% of total) of Cote d'Ivoire in 2006 to that in 2009?
Your answer should be very brief. 1.14. What is the ratio of the Electricity production(% of total) in Ecuador in 2006 to that in 2009?
Offer a terse response. 1.14. What is the ratio of the Electricity production(% of total) in Latin America(all income levels) in 2006 to that in 2010?
Give a very brief answer. 0.84. What is the ratio of the Electricity production(% of total) of Brazil in 2006 to that in 2010?
Provide a succinct answer. 0.62. What is the ratio of the Electricity production(% of total) of Cote d'Ivoire in 2006 to that in 2010?
Provide a succinct answer. 1.01. What is the ratio of the Electricity production(% of total) in Ecuador in 2006 to that in 2010?
Provide a succinct answer. 1.08. What is the ratio of the Electricity production(% of total) of Latin America(all income levels) in 2007 to that in 2008?
Your answer should be compact. 0.93. What is the ratio of the Electricity production(% of total) in Brazil in 2007 to that in 2008?
Provide a succinct answer. 0.56. What is the ratio of the Electricity production(% of total) of Cote d'Ivoire in 2007 to that in 2008?
Offer a terse response. 1.01. What is the ratio of the Electricity production(% of total) of Ecuador in 2007 to that in 2008?
Provide a succinct answer. 1.31. What is the ratio of the Electricity production(% of total) of Latin America(all income levels) in 2007 to that in 2009?
Offer a terse response. 0.95. What is the ratio of the Electricity production(% of total) in Brazil in 2007 to that in 2009?
Give a very brief answer. 1.22. What is the ratio of the Electricity production(% of total) in Cote d'Ivoire in 2007 to that in 2009?
Make the answer very short. 1.06. What is the ratio of the Electricity production(% of total) in Ecuador in 2007 to that in 2009?
Make the answer very short. 1.15. What is the ratio of the Electricity production(% of total) in Latin America(all income levels) in 2007 to that in 2010?
Your response must be concise. 0.86. What is the ratio of the Electricity production(% of total) of Brazil in 2007 to that in 2010?
Provide a succinct answer. 0.49. What is the ratio of the Electricity production(% of total) of Cote d'Ivoire in 2007 to that in 2010?
Provide a succinct answer. 0.94. What is the ratio of the Electricity production(% of total) of Ecuador in 2007 to that in 2010?
Offer a terse response. 1.1. What is the ratio of the Electricity production(% of total) in Latin America(all income levels) in 2008 to that in 2009?
Ensure brevity in your answer.  1.02. What is the ratio of the Electricity production(% of total) of Brazil in 2008 to that in 2009?
Your response must be concise. 2.17. What is the ratio of the Electricity production(% of total) in Cote d'Ivoire in 2008 to that in 2009?
Provide a succinct answer. 1.05. What is the ratio of the Electricity production(% of total) in Ecuador in 2008 to that in 2009?
Give a very brief answer. 0.88. What is the ratio of the Electricity production(% of total) in Latin America(all income levels) in 2008 to that in 2010?
Give a very brief answer. 0.93. What is the ratio of the Electricity production(% of total) in Brazil in 2008 to that in 2010?
Ensure brevity in your answer.  0.88. What is the ratio of the Electricity production(% of total) in Cote d'Ivoire in 2008 to that in 2010?
Ensure brevity in your answer.  0.93. What is the ratio of the Electricity production(% of total) of Ecuador in 2008 to that in 2010?
Offer a terse response. 0.83. What is the ratio of the Electricity production(% of total) in Latin America(all income levels) in 2009 to that in 2010?
Your response must be concise. 0.91. What is the ratio of the Electricity production(% of total) in Brazil in 2009 to that in 2010?
Ensure brevity in your answer.  0.4. What is the ratio of the Electricity production(% of total) of Cote d'Ivoire in 2009 to that in 2010?
Give a very brief answer. 0.89. What is the difference between the highest and the second highest Electricity production(% of total) of Latin America(all income levels)?
Your response must be concise. 1.59. What is the difference between the highest and the second highest Electricity production(% of total) in Brazil?
Ensure brevity in your answer.  0.86. What is the difference between the highest and the second highest Electricity production(% of total) of Cote d'Ivoire?
Provide a succinct answer. 1.61. What is the difference between the highest and the second highest Electricity production(% of total) in Ecuador?
Your answer should be very brief. 0.12. What is the difference between the highest and the lowest Electricity production(% of total) of Latin America(all income levels)?
Ensure brevity in your answer.  3.66. What is the difference between the highest and the lowest Electricity production(% of total) of Brazil?
Your response must be concise. 4.21. What is the difference between the highest and the lowest Electricity production(% of total) in Cote d'Ivoire?
Your answer should be compact. 10.37. What is the difference between the highest and the lowest Electricity production(% of total) of Ecuador?
Your answer should be very brief. 2.93. 